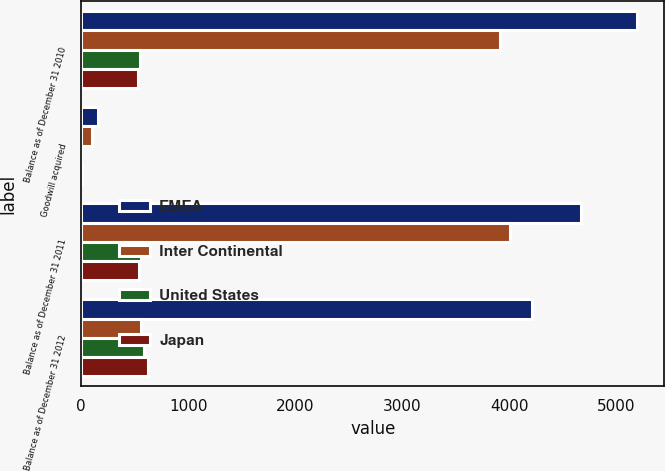Convert chart to OTSL. <chart><loc_0><loc_0><loc_500><loc_500><stacked_bar_chart><ecel><fcel>Balance as of December 31 2010<fcel>Goodwill acquired<fcel>Balance as of December 31 2011<fcel>Balance as of December 31 2012<nl><fcel>EMEA<fcel>5189<fcel>161<fcel>4667<fcel>4209<nl><fcel>Inter Continental<fcel>3915<fcel>99<fcel>4004<fcel>556<nl><fcel>United States<fcel>551<fcel>1<fcel>554<fcel>585<nl><fcel>Japan<fcel>531<fcel>5<fcel>536<fcel>623<nl></chart> 